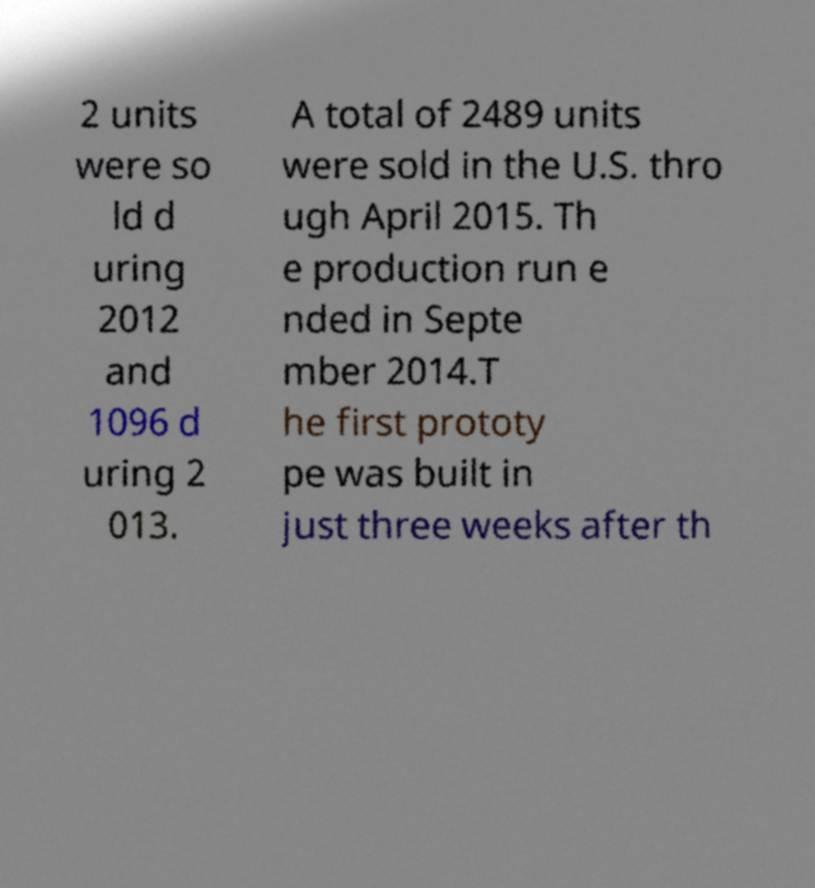Can you read and provide the text displayed in the image?This photo seems to have some interesting text. Can you extract and type it out for me? 2 units were so ld d uring 2012 and 1096 d uring 2 013. A total of 2489 units were sold in the U.S. thro ugh April 2015. Th e production run e nded in Septe mber 2014.T he first prototy pe was built in just three weeks after th 